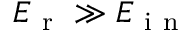Convert formula to latex. <formula><loc_0><loc_0><loc_500><loc_500>E _ { r } \gg E _ { i n }</formula> 